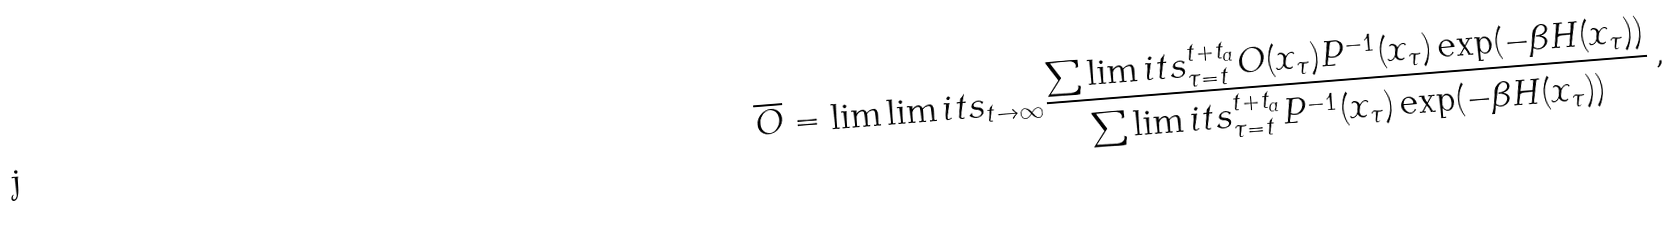Convert formula to latex. <formula><loc_0><loc_0><loc_500><loc_500>\overline { O } = \lim \lim i t s _ { t \to \infty } \frac { \sum \lim i t s _ { \tau = t } ^ { t + t _ { a } } O ( x _ { \tau } ) P ^ { - 1 } ( x _ { \tau } ) \exp ( - \beta H ( x _ { \tau } ) ) } { \sum \lim i t s _ { \tau = t } ^ { t + t _ { a } } P ^ { - 1 } ( x _ { \tau } ) \exp ( - \beta H ( x _ { \tau } ) ) } \, ,</formula> 